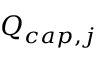<formula> <loc_0><loc_0><loc_500><loc_500>Q _ { c a p , j }</formula> 